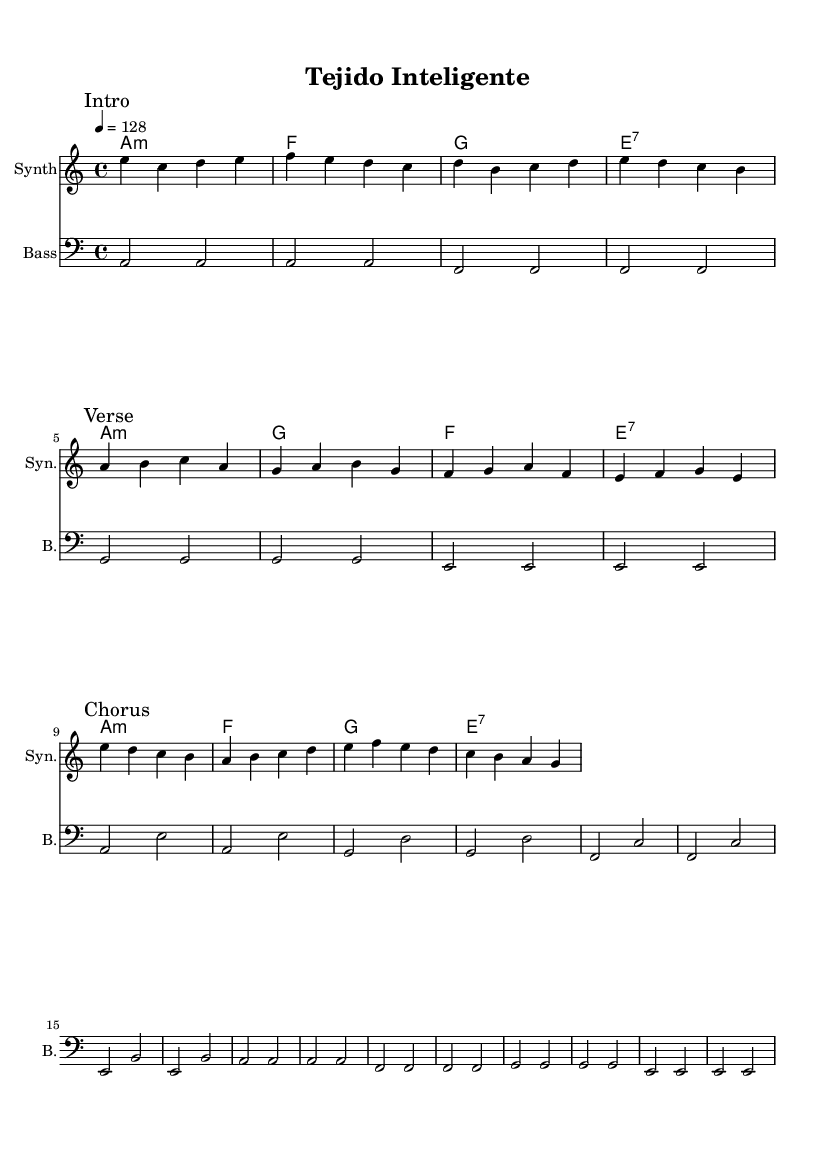What is the key signature of this music? The key signature is A minor, which has no sharps or flats.
Answer: A minor What is the time signature of this music? The time signature is indicated at the beginning of the score and shows there are four beats in each measure.
Answer: 4/4 What is the tempo marking for this piece? The tempo marking indicates a speed of 128 beats per minute, commonly notated in the score as "4 = 128".
Answer: 128 What is the first marked section of the music? The first marked section of the music is labeled as "Intro", which appears at the beginning of the melody.
Answer: Intro How many measures are in the "Chorus" section? By counting the number of vertical lines in the "Chorus" section, there are four measures present in that part.
Answer: 4 Which chord appears first in the harmonies? The first chord listed in the harmonies is A minor, as it is the first chord indicated in the chord changes.
Answer: A:m How many instruments are indicated in this score? The score specifies three instruments: one for synth, one for bass, and one for chord names, totaling three distinct entries.
Answer: 3 